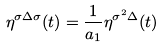<formula> <loc_0><loc_0><loc_500><loc_500>\eta ^ { \sigma \Delta \sigma } ( t ) = \frac { 1 } { a _ { 1 } } \eta ^ { \sigma ^ { 2 } \Delta } ( t )</formula> 